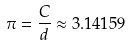<formula> <loc_0><loc_0><loc_500><loc_500>\pi = \frac { C } { d } \approx 3 . 1 4 1 5 9</formula> 